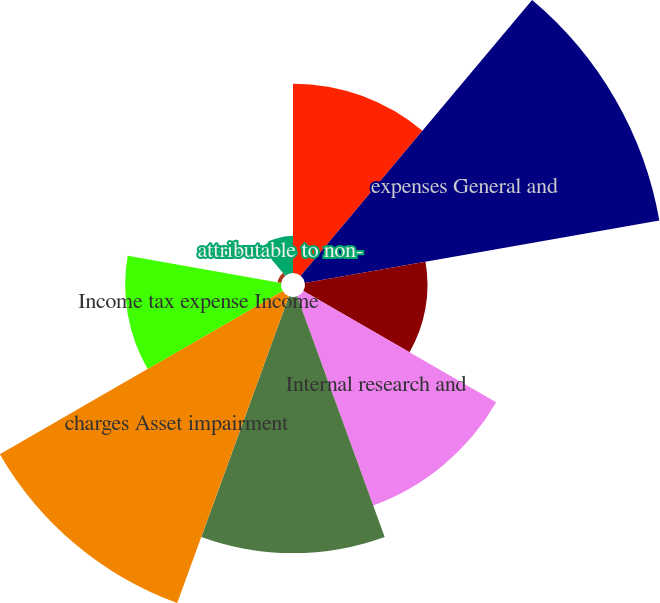Convert chart. <chart><loc_0><loc_0><loc_500><loc_500><pie_chart><fcel>Cost of revenues Selling<fcel>expenses General and<fcel>administrative Bid and<fcel>Internal research and<fcel>Bad debt expense<fcel>charges Asset impairment<fcel>Income tax expense Income<fcel>continuing operations<fcel>attributable to non-<nl><fcel>11.31%<fcel>21.51%<fcel>7.32%<fcel>13.3%<fcel>15.3%<fcel>19.51%<fcel>9.31%<fcel>0.22%<fcel>2.22%<nl></chart> 